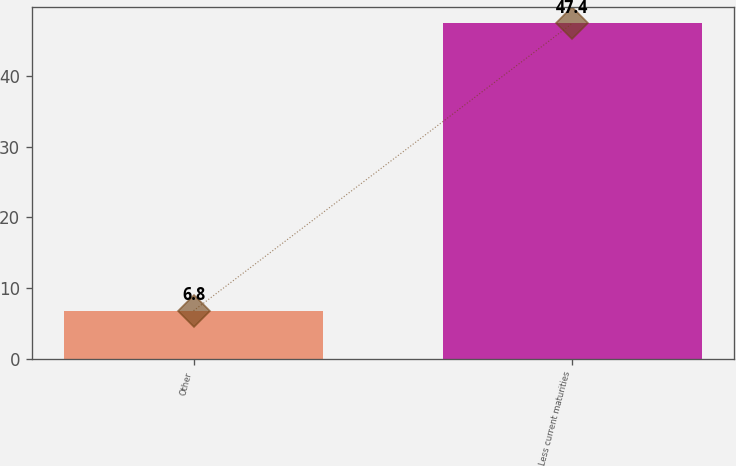Convert chart. <chart><loc_0><loc_0><loc_500><loc_500><bar_chart><fcel>Other<fcel>Less current maturities<nl><fcel>6.8<fcel>47.4<nl></chart> 